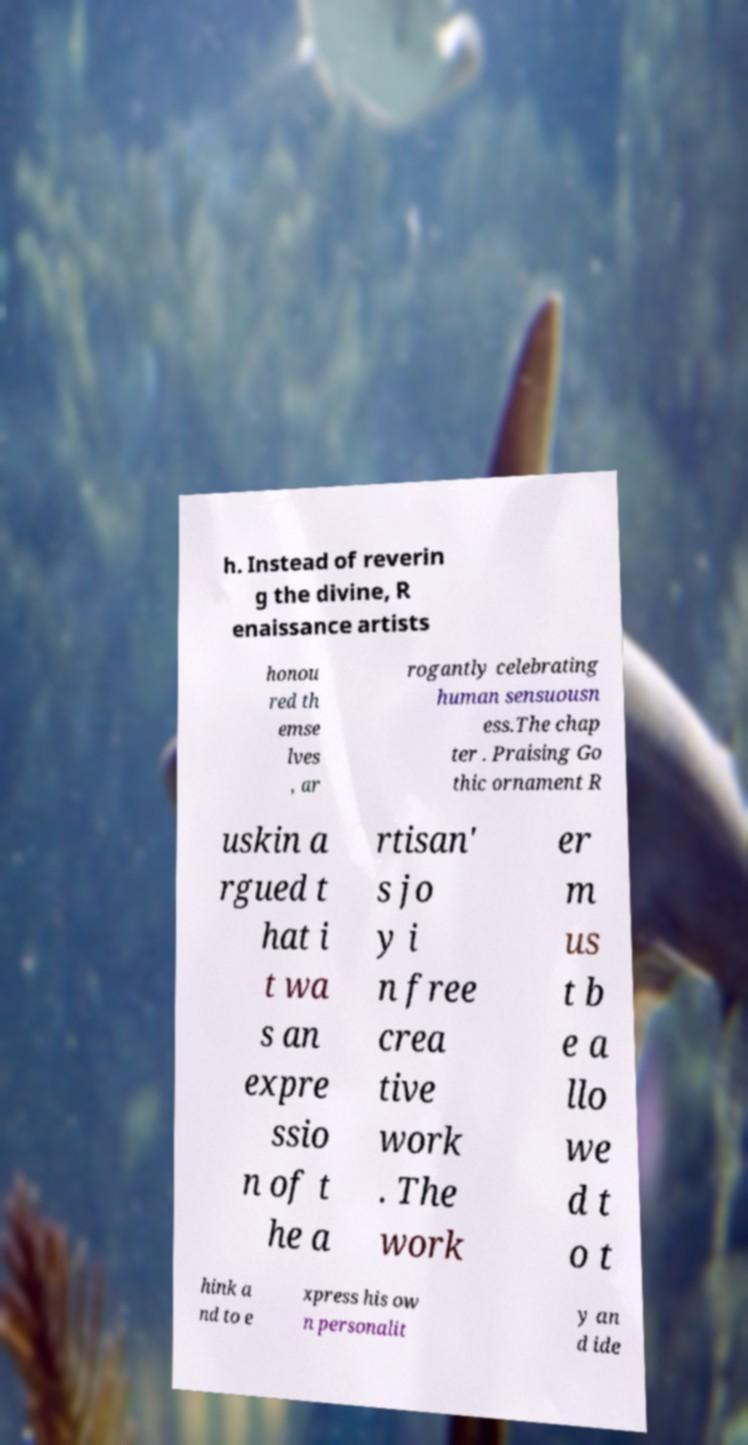For documentation purposes, I need the text within this image transcribed. Could you provide that? h. Instead of reverin g the divine, R enaissance artists honou red th emse lves , ar rogantly celebrating human sensuousn ess.The chap ter . Praising Go thic ornament R uskin a rgued t hat i t wa s an expre ssio n of t he a rtisan' s jo y i n free crea tive work . The work er m us t b e a llo we d t o t hink a nd to e xpress his ow n personalit y an d ide 